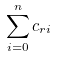<formula> <loc_0><loc_0><loc_500><loc_500>\sum _ { i = 0 } ^ { n } c _ { r i }</formula> 